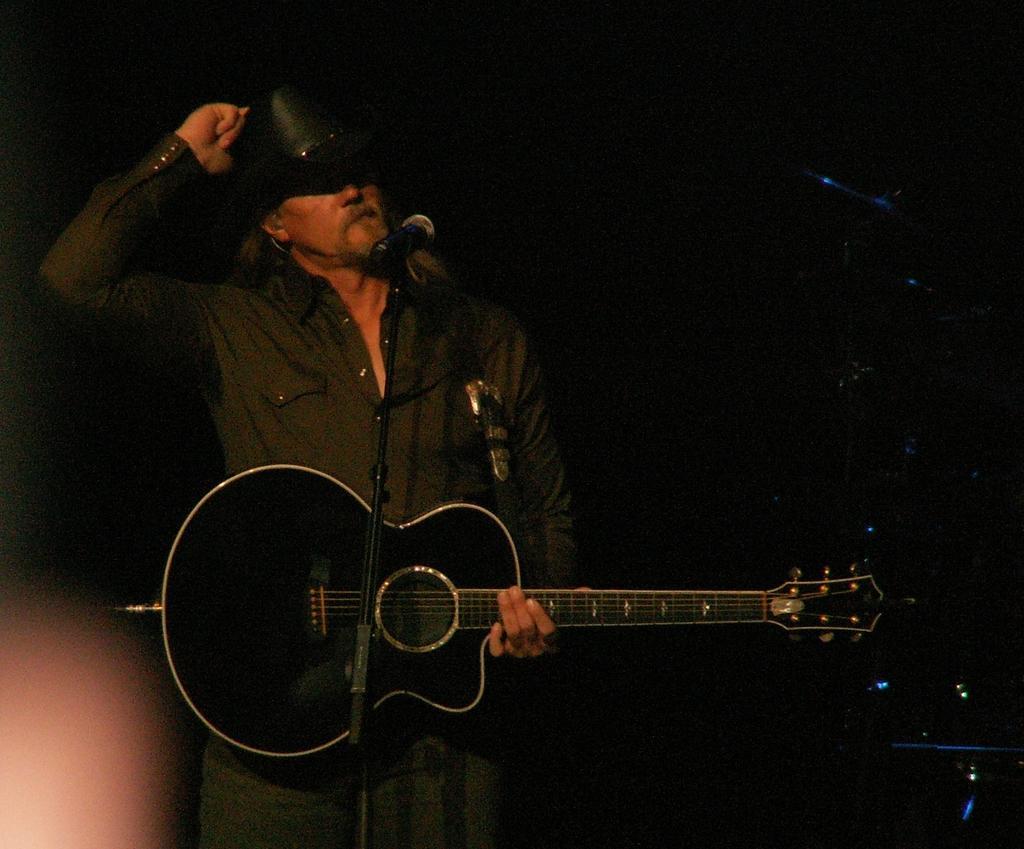Please provide a concise description of this image. In this Image I see man who is standing and he is wearing a cap on his head, I can also see he is holding a guitar and I see a mic in front of him. 